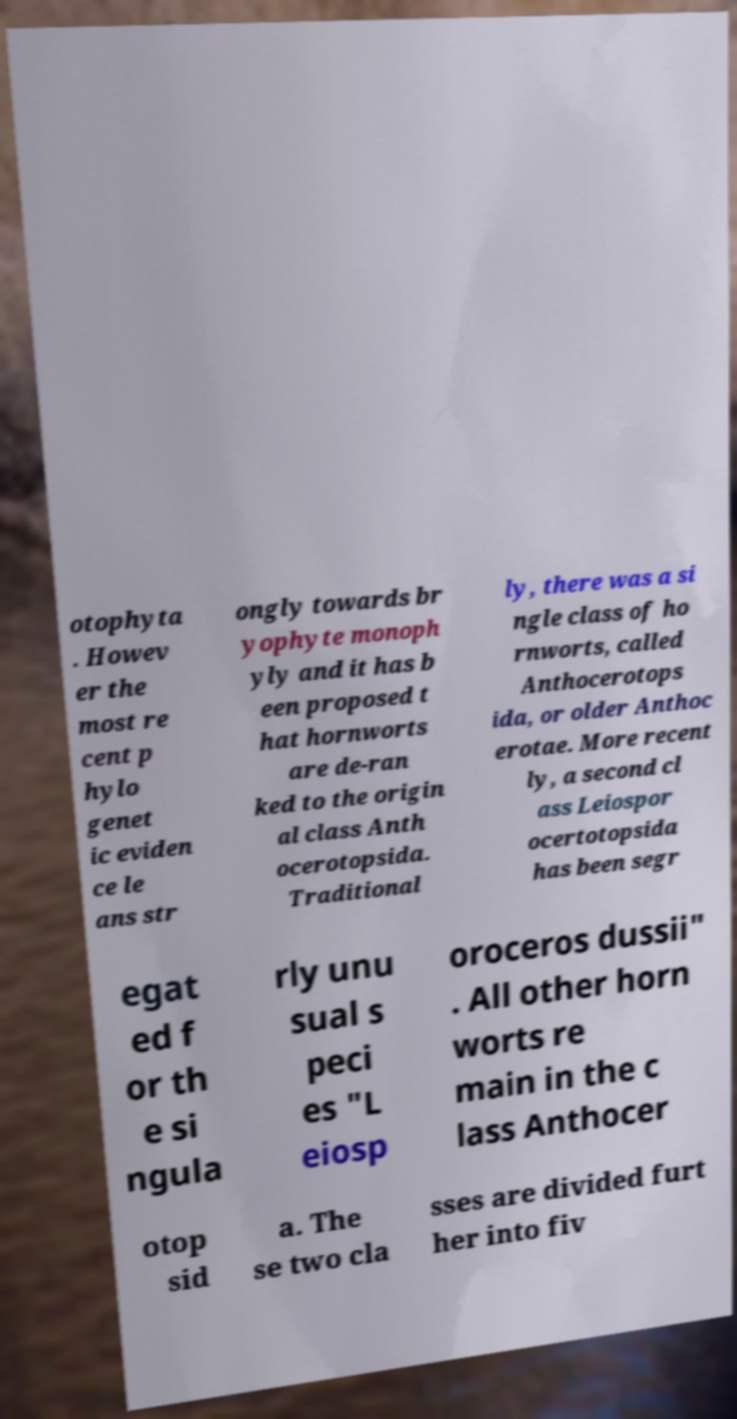There's text embedded in this image that I need extracted. Can you transcribe it verbatim? otophyta . Howev er the most re cent p hylo genet ic eviden ce le ans str ongly towards br yophyte monoph yly and it has b een proposed t hat hornworts are de-ran ked to the origin al class Anth ocerotopsida. Traditional ly, there was a si ngle class of ho rnworts, called Anthocerotops ida, or older Anthoc erotae. More recent ly, a second cl ass Leiospor ocertotopsida has been segr egat ed f or th e si ngula rly unu sual s peci es "L eiosp oroceros dussii" . All other horn worts re main in the c lass Anthocer otop sid a. The se two cla sses are divided furt her into fiv 